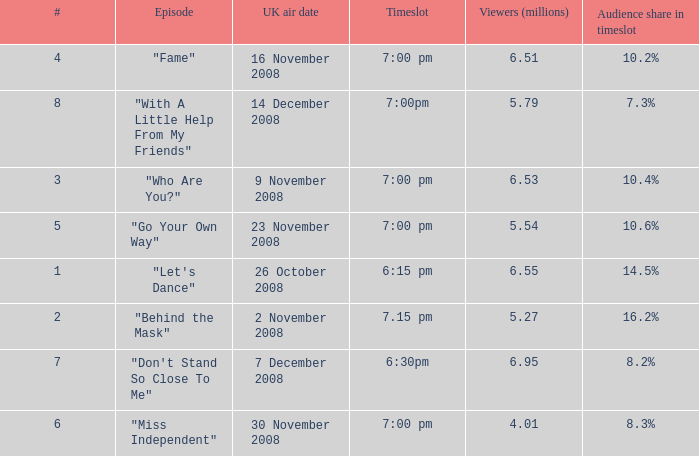Name the most number for viewers being 6.95 7.0. 